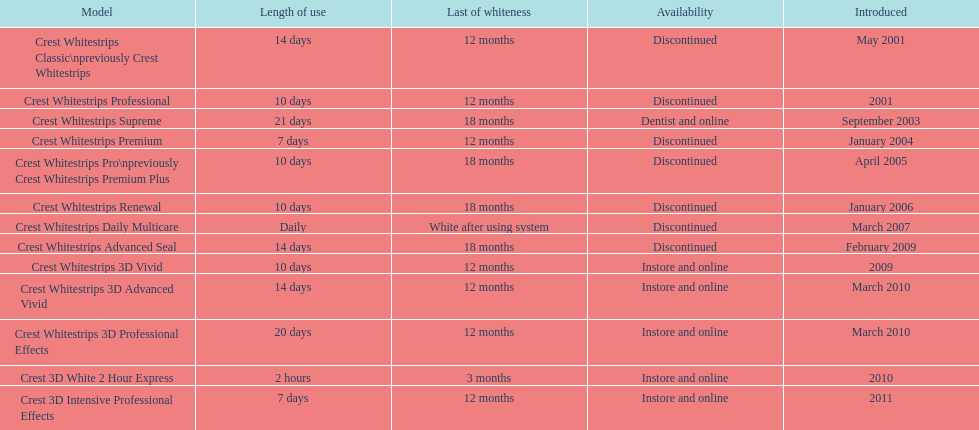Does the crest white strips pro last as long as the crest white strips renewal? Yes. 